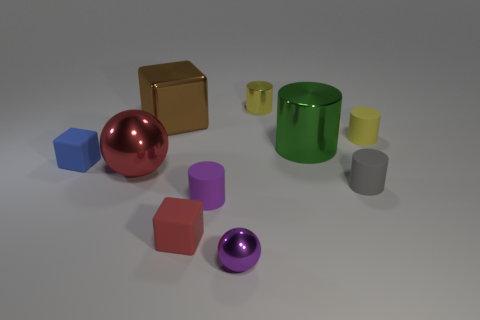Subtract 1 cylinders. How many cylinders are left? 4 Subtract all purple cylinders. How many cylinders are left? 4 Subtract all tiny shiny cylinders. How many cylinders are left? 4 Subtract all red cylinders. Subtract all purple cubes. How many cylinders are left? 5 Subtract all cubes. How many objects are left? 7 Subtract all tiny gray rubber cylinders. Subtract all yellow shiny cylinders. How many objects are left? 8 Add 5 gray rubber things. How many gray rubber things are left? 6 Add 7 brown metal cylinders. How many brown metal cylinders exist? 7 Subtract 0 green balls. How many objects are left? 10 